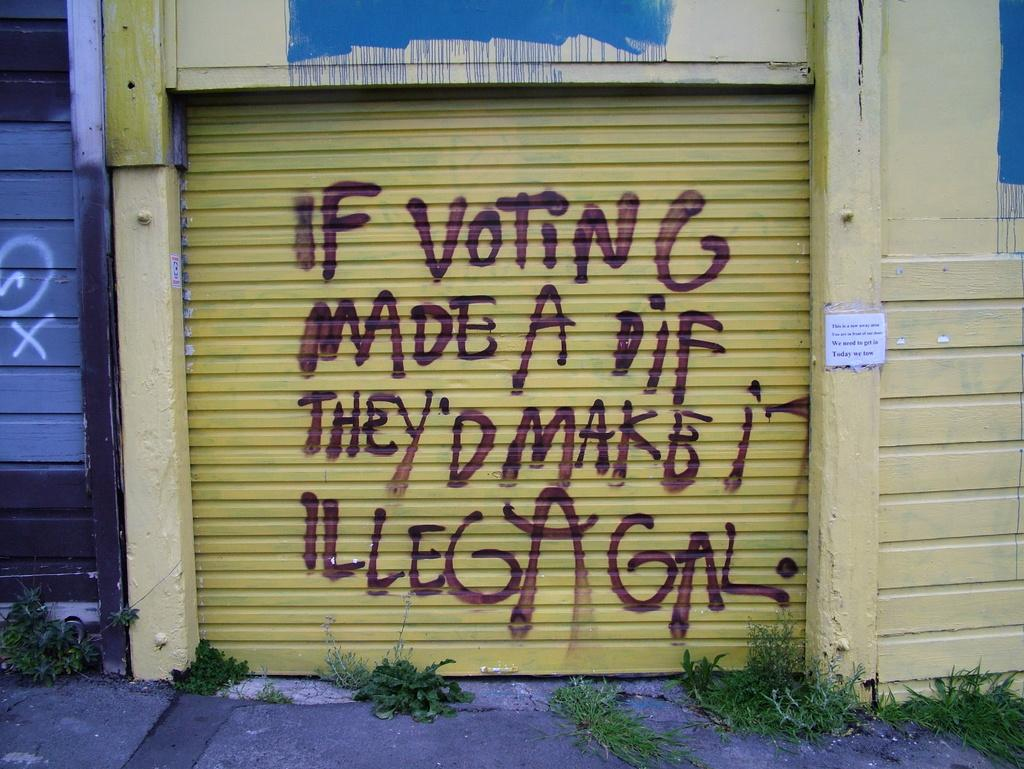What is the main subject of the image? The main subject of the image is the shutter of a building. What can be seen on the shutter? There is written text on the shutter. What else is present in the image? There is a board on a wall and plants visible in the image. Can you tell me how many apples are on the fireman's head in the image? There is no fireman or apple present in the image. Is the baseball player visible in the image? There is no baseball player or baseball-related object present in the image. 